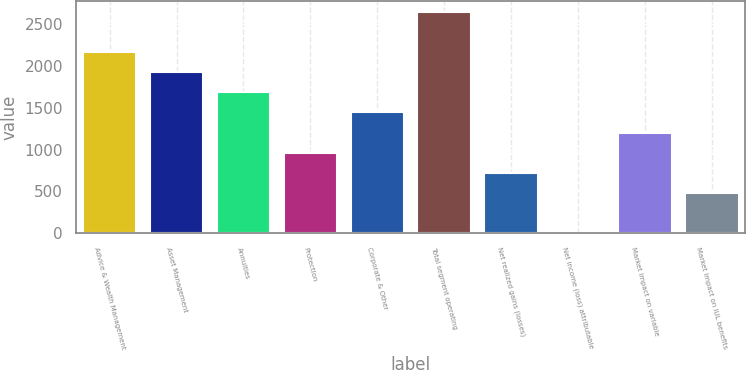Convert chart to OTSL. <chart><loc_0><loc_0><loc_500><loc_500><bar_chart><fcel>Advice & Wealth Management<fcel>Asset Management<fcel>Annuities<fcel>Protection<fcel>Corporate & Other<fcel>Total segment operating<fcel>Net realized gains (losses)<fcel>Net income (loss) attributable<fcel>Market impact on variable<fcel>Market impact on IUL benefits<nl><fcel>2162.9<fcel>1922.8<fcel>1682.7<fcel>962.4<fcel>1442.6<fcel>2643.1<fcel>722.3<fcel>2<fcel>1202.5<fcel>482.2<nl></chart> 